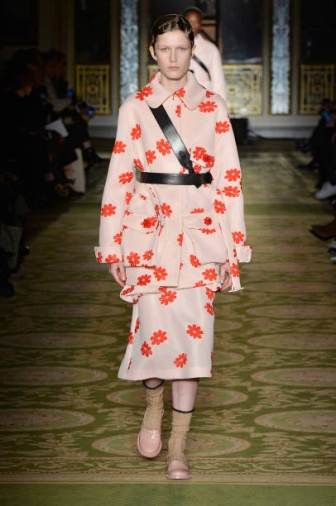Imagine this fashion show is part of a global event. How do you think the fashion world will react to this collection? If this fashion show were part of a global event, it would likely garner significant attention from fashion enthusiasts and critics alike. The bold use of colors and patterns, combined with the unexpected accessory choices like pink socks and beige heels, would be discussed extensively. Some might praise the innovative and daring approach, while others might critique it for breaking conventional fashion rules. Overall, the show would spark conversations about contemporary fashion trends and the importance of creativity and boldness in modern design. Could you imagine this outfit in a different scenario, like a story or a movie? Absolutely! Picture a whimsical fantasy film where the protagonist, a young and daring fashion designer, finds herself transported to a magical realm where each outfit she creates comes to life and has special powers. This particular pink dress adorned with red flowers could be the key to unlocking a secret garden in the magical world, where every flower on the dress corresponds to a rare, blooming flower in the garden. The quirky pink socks might provide the protagonist with the ability to walk on air, giving her an edge over her adversaries as she embarks on an adventurous quest. This outfit could symbolize hope, creativity, and the power of imagination, weaving a fantastical tale around its unique elements. 